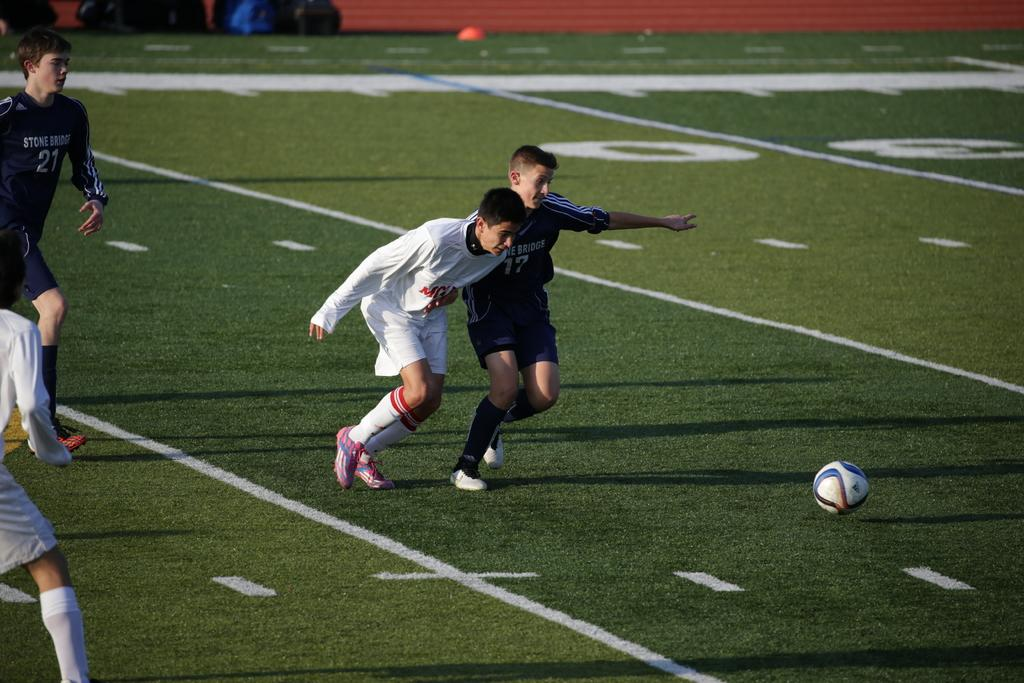Provide a one-sentence caption for the provided image. soccer players wearing a blue jersey that says Stone Bridge. 